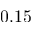<formula> <loc_0><loc_0><loc_500><loc_500>0 . 1 5</formula> 